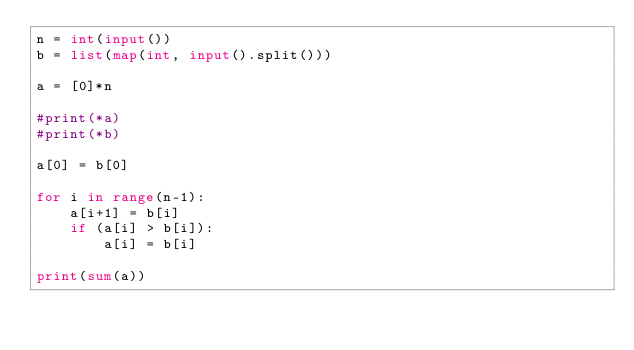<code> <loc_0><loc_0><loc_500><loc_500><_Python_>n = int(input())
b = list(map(int, input().split()))

a = [0]*n

#print(*a)
#print(*b)

a[0] = b[0]

for i in range(n-1):
    a[i+1] = b[i]
    if (a[i] > b[i]):
        a[i] = b[i]

print(sum(a))
</code> 